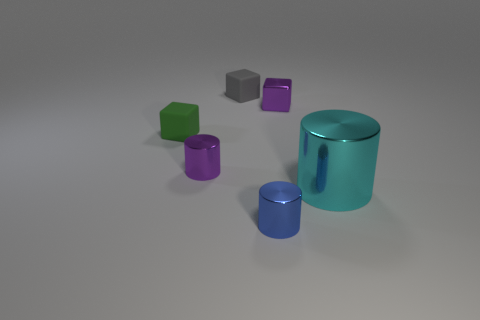Is there anything else that has the same size as the cyan thing?
Offer a very short reply. No. Is there anything else that is the same color as the small shiny block?
Your answer should be very brief. Yes. How many cyan objects are there?
Ensure brevity in your answer.  1. There is a thing that is both behind the small green rubber cube and to the left of the purple metal cube; what shape is it?
Offer a very short reply. Cube. There is a rubber thing behind the tiny cube right of the metallic thing in front of the large cyan metallic cylinder; what shape is it?
Keep it short and to the point. Cube. What is the material of the object that is to the right of the tiny blue shiny object and to the left of the big thing?
Offer a terse response. Metal. How many purple blocks have the same size as the green object?
Provide a short and direct response. 1. How many metal things are tiny brown cubes or cubes?
Offer a terse response. 1. What is the material of the tiny gray block?
Your answer should be very brief. Rubber. What number of shiny blocks are to the right of the large cylinder?
Offer a very short reply. 0. 